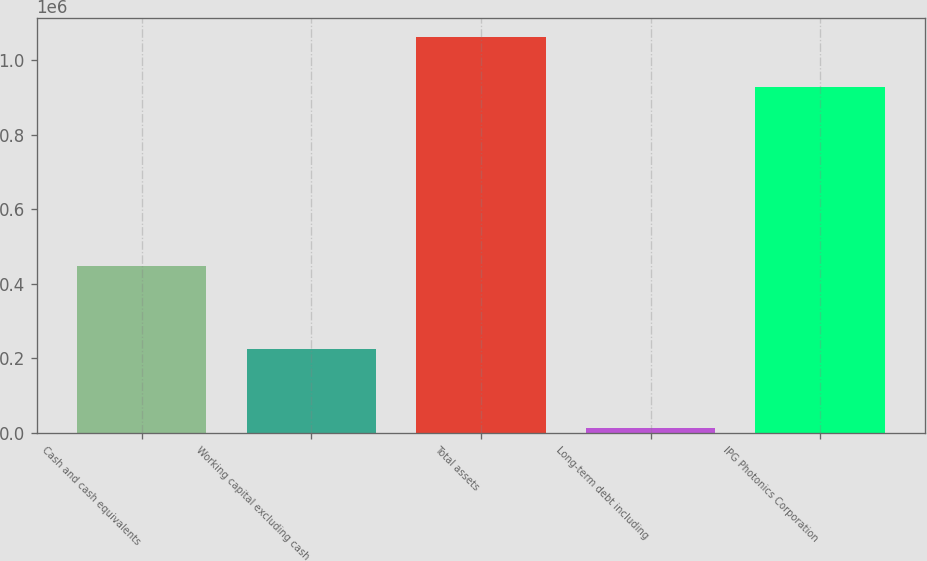Convert chart to OTSL. <chart><loc_0><loc_0><loc_500><loc_500><bar_chart><fcel>Cash and cash equivalents<fcel>Working capital excluding cash<fcel>Total assets<fcel>Long-term debt including<fcel>IPG Photonics Corporation<nl><fcel>448776<fcel>225365<fcel>1.06122e+06<fcel>12666<fcel>927969<nl></chart> 